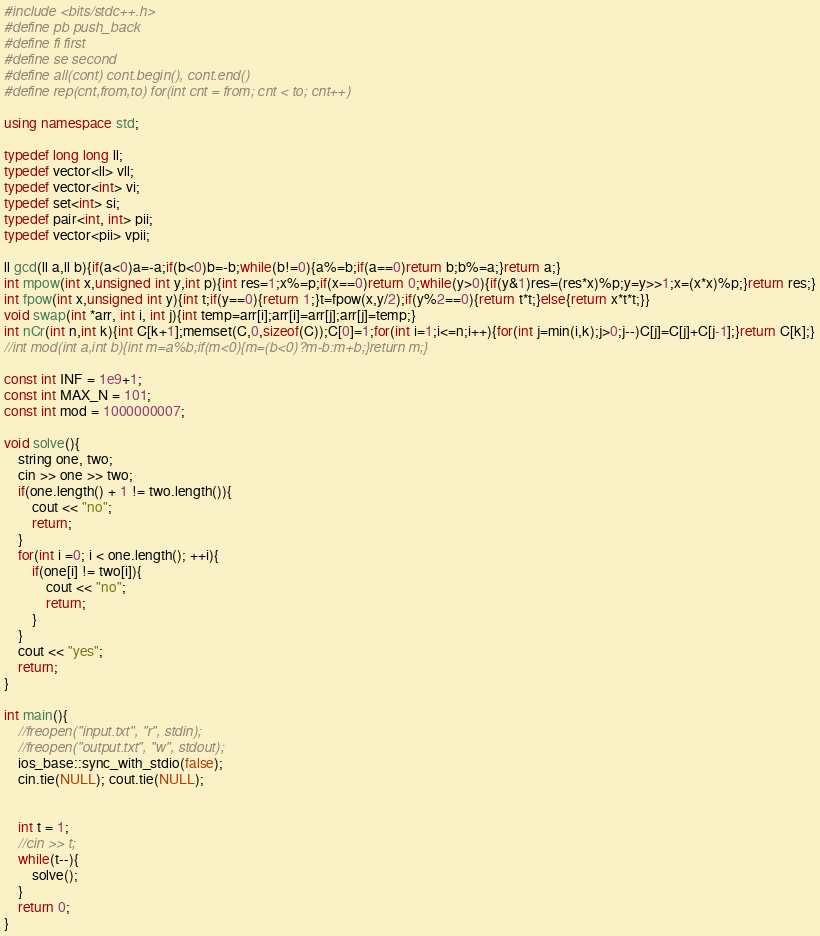Convert code to text. <code><loc_0><loc_0><loc_500><loc_500><_C++_>#include <bits/stdc++.h>
#define pb push_back
#define fi first
#define se second
#define all(cont) cont.begin(), cont.end()
#define rep(cnt,from,to) for(int cnt = from; cnt < to; cnt++)
 
using namespace std;
 
typedef long long ll;
typedef vector<ll> vll;
typedef vector<int> vi;
typedef set<int> si;
typedef pair<int, int> pii;
typedef vector<pii> vpii;
 
ll gcd(ll a,ll b){if(a<0)a=-a;if(b<0)b=-b;while(b!=0){a%=b;if(a==0)return b;b%=a;}return a;}
int mpow(int x,unsigned int y,int p){int res=1;x%=p;if(x==0)return 0;while(y>0){if(y&1)res=(res*x)%p;y=y>>1;x=(x*x)%p;}return res;}
int fpow(int x,unsigned int y){int t;if(y==0){return 1;}t=fpow(x,y/2);if(y%2==0){return t*t;}else{return x*t*t;}}
void swap(int *arr, int i, int j){int temp=arr[i];arr[i]=arr[j];arr[j]=temp;}
int nCr(int n,int k){int C[k+1];memset(C,0,sizeof(C));C[0]=1;for(int i=1;i<=n;i++){for(int j=min(i,k);j>0;j--)C[j]=C[j]+C[j-1];}return C[k];}
//int mod(int a,int b){int m=a%b;if(m<0){m=(b<0)?m-b:m+b;}return m;}
 
const int INF = 1e9+1;
const int MAX_N = 101;
const int mod = 1000000007;

void solve(){
	string one, two;
	cin >> one >> two;
	if(one.length() + 1 != two.length()){
		cout << "no";
		return;
	}
	for(int i =0; i < one.length(); ++i){
		if(one[i] != two[i]){
			cout << "no";
			return;
		}
	}
	cout << "yes";
	return;
}
 
int main(){
	//freopen("input.txt", "r", stdin);
    //freopen("output.txt", "w", stdout);
	ios_base::sync_with_stdio(false);
	cin.tie(NULL); cout.tie(NULL);
	
	
	int t = 1;
	//cin >> t;
	while(t--){
		solve();
	}	
	return 0;
}</code> 